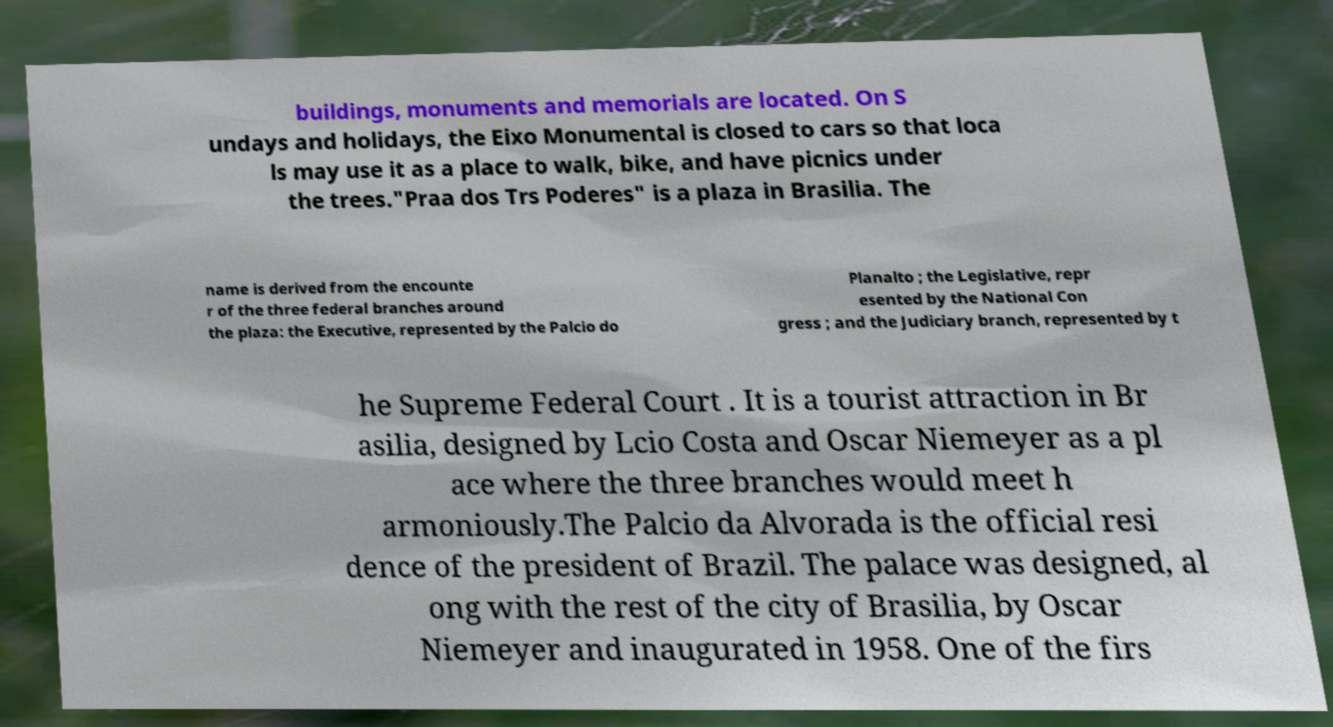Can you accurately transcribe the text from the provided image for me? buildings, monuments and memorials are located. On S undays and holidays, the Eixo Monumental is closed to cars so that loca ls may use it as a place to walk, bike, and have picnics under the trees."Praa dos Trs Poderes" is a plaza in Brasilia. The name is derived from the encounte r of the three federal branches around the plaza: the Executive, represented by the Palcio do Planalto ; the Legislative, repr esented by the National Con gress ; and the Judiciary branch, represented by t he Supreme Federal Court . It is a tourist attraction in Br asilia, designed by Lcio Costa and Oscar Niemeyer as a pl ace where the three branches would meet h armoniously.The Palcio da Alvorada is the official resi dence of the president of Brazil. The palace was designed, al ong with the rest of the city of Brasilia, by Oscar Niemeyer and inaugurated in 1958. One of the firs 